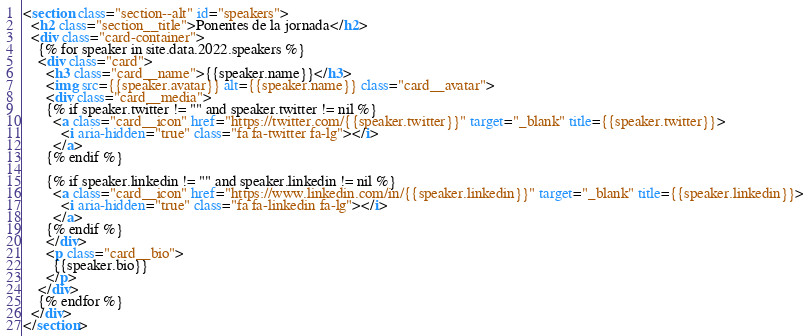<code> <loc_0><loc_0><loc_500><loc_500><_HTML_><section class="section--alt" id="speakers">
  <h2 class="section__title">Ponentes de la jornada</h2>
  <div class="card-container">
    {% for speaker in site.data.2022.speakers %}
    <div class="card">
      <h3 class="card__name">{{speaker.name}}</h3>
      <img src={{speaker.avatar}} alt={{speaker.name}} class="card__avatar">
      <div class="card__media">
      {% if speaker.twitter != "" and speaker.twitter != nil %}
        <a class="card__icon" href="https://twitter.com/{{speaker.twitter}}" target="_blank" title={{speaker.twitter}}>
          <i aria-hidden="true" class="fa fa-twitter fa-lg"></i>
        </a>
      {% endif %}

      {% if speaker.linkedin != "" and speaker.linkedin != nil %}
        <a class="card__icon" href="https://www.linkedin.com/in/{{speaker.linkedin}}" target="_blank" title={{speaker.linkedin}}>
          <i aria-hidden="true" class="fa fa-linkedin fa-lg"></i>
        </a>
      {% endif %}
      </div>
      <p class="card__bio">
        {{speaker.bio}}
      </p>
    </div>
    {% endfor %}
  </div>
</section>
</code> 